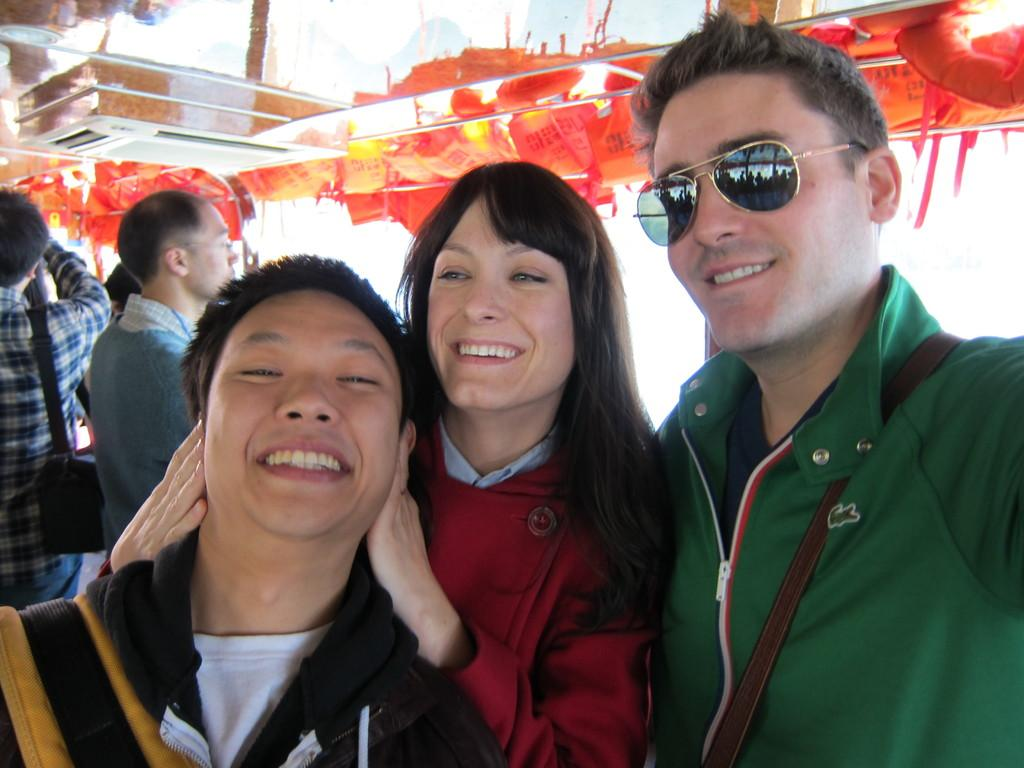How many people are present in the image? There are three people in the image. What is the facial expression of the people in the image? The people are smiling. Can you describe any specific accessory worn by one of the people? One person is wearing goggles. What can be seen in the background of the image? There are decorative pieces and other people in the background. Is there any object visible in the background that might be used for carrying items? Yes, there is a bag visible in the background. Where is the faucet located in the image? There is no faucet present in the image. What type of boundary can be seen separating the people in the image? There is no boundary visible in the image; the people are not separated by any physical barrier. 